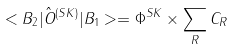<formula> <loc_0><loc_0><loc_500><loc_500>< B _ { 2 } | { \hat { O } } ^ { ( S K ) } | B _ { 1 } > = \Phi ^ { S K } \times \sum _ { R } C _ { R }</formula> 